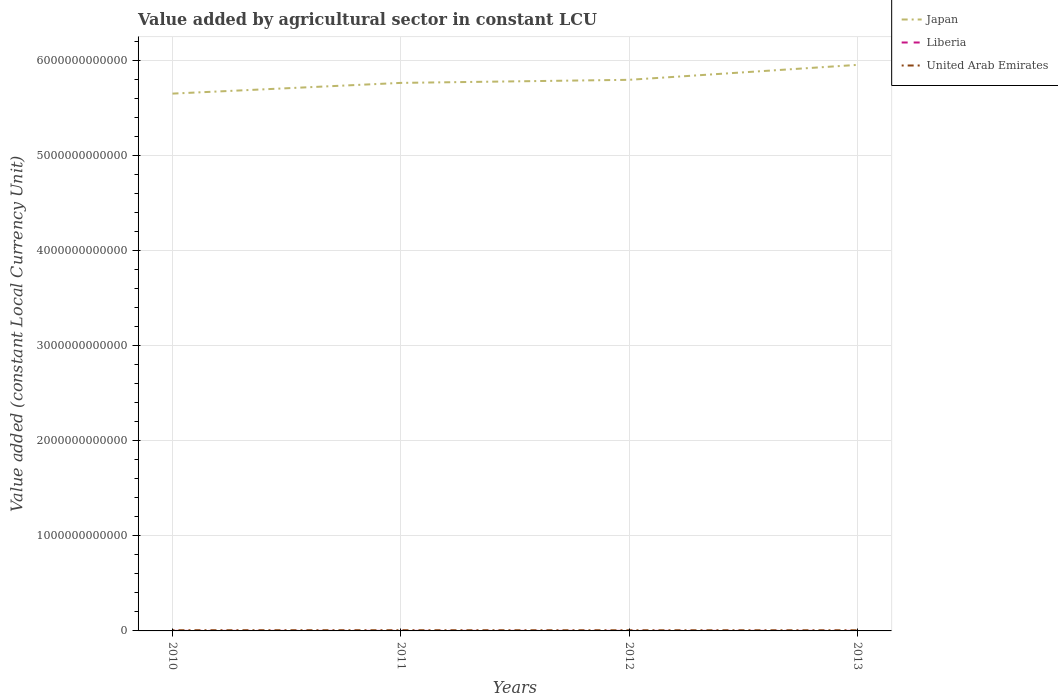How many different coloured lines are there?
Keep it short and to the point. 3. Does the line corresponding to United Arab Emirates intersect with the line corresponding to Japan?
Provide a succinct answer. No. Across all years, what is the maximum value added by agricultural sector in Japan?
Offer a terse response. 5.66e+12. What is the total value added by agricultural sector in Japan in the graph?
Offer a terse response. -1.13e+11. What is the difference between the highest and the second highest value added by agricultural sector in Liberia?
Offer a terse response. 2.97e+07. What is the difference between two consecutive major ticks on the Y-axis?
Provide a short and direct response. 1.00e+12. Are the values on the major ticks of Y-axis written in scientific E-notation?
Your response must be concise. No. Does the graph contain any zero values?
Make the answer very short. No. Where does the legend appear in the graph?
Keep it short and to the point. Top right. What is the title of the graph?
Make the answer very short. Value added by agricultural sector in constant LCU. Does "Angola" appear as one of the legend labels in the graph?
Offer a terse response. No. What is the label or title of the Y-axis?
Offer a terse response. Value added (constant Local Currency Unit). What is the Value added (constant Local Currency Unit) of Japan in 2010?
Keep it short and to the point. 5.66e+12. What is the Value added (constant Local Currency Unit) of Liberia in 2010?
Provide a succinct answer. 3.45e+08. What is the Value added (constant Local Currency Unit) in United Arab Emirates in 2010?
Make the answer very short. 7.35e+09. What is the Value added (constant Local Currency Unit) in Japan in 2011?
Keep it short and to the point. 5.77e+12. What is the Value added (constant Local Currency Unit) of Liberia in 2011?
Your answer should be very brief. 3.59e+08. What is the Value added (constant Local Currency Unit) of United Arab Emirates in 2011?
Offer a very short reply. 7.36e+09. What is the Value added (constant Local Currency Unit) of Japan in 2012?
Offer a terse response. 5.80e+12. What is the Value added (constant Local Currency Unit) in Liberia in 2012?
Offer a terse response. 3.66e+08. What is the Value added (constant Local Currency Unit) in United Arab Emirates in 2012?
Provide a short and direct response. 6.95e+09. What is the Value added (constant Local Currency Unit) in Japan in 2013?
Give a very brief answer. 5.96e+12. What is the Value added (constant Local Currency Unit) of Liberia in 2013?
Make the answer very short. 3.75e+08. What is the Value added (constant Local Currency Unit) of United Arab Emirates in 2013?
Your answer should be compact. 6.93e+09. Across all years, what is the maximum Value added (constant Local Currency Unit) in Japan?
Provide a succinct answer. 5.96e+12. Across all years, what is the maximum Value added (constant Local Currency Unit) of Liberia?
Offer a very short reply. 3.75e+08. Across all years, what is the maximum Value added (constant Local Currency Unit) in United Arab Emirates?
Your answer should be very brief. 7.36e+09. Across all years, what is the minimum Value added (constant Local Currency Unit) of Japan?
Offer a terse response. 5.66e+12. Across all years, what is the minimum Value added (constant Local Currency Unit) in Liberia?
Give a very brief answer. 3.45e+08. Across all years, what is the minimum Value added (constant Local Currency Unit) in United Arab Emirates?
Offer a very short reply. 6.93e+09. What is the total Value added (constant Local Currency Unit) of Japan in the graph?
Give a very brief answer. 2.32e+13. What is the total Value added (constant Local Currency Unit) of Liberia in the graph?
Your response must be concise. 1.45e+09. What is the total Value added (constant Local Currency Unit) in United Arab Emirates in the graph?
Your answer should be very brief. 2.86e+1. What is the difference between the Value added (constant Local Currency Unit) in Japan in 2010 and that in 2011?
Provide a succinct answer. -1.13e+11. What is the difference between the Value added (constant Local Currency Unit) in Liberia in 2010 and that in 2011?
Your answer should be very brief. -1.34e+07. What is the difference between the Value added (constant Local Currency Unit) of United Arab Emirates in 2010 and that in 2011?
Provide a succinct answer. -1.20e+07. What is the difference between the Value added (constant Local Currency Unit) in Japan in 2010 and that in 2012?
Keep it short and to the point. -1.45e+11. What is the difference between the Value added (constant Local Currency Unit) of Liberia in 2010 and that in 2012?
Provide a succinct answer. -2.03e+07. What is the difference between the Value added (constant Local Currency Unit) in United Arab Emirates in 2010 and that in 2012?
Offer a very short reply. 3.94e+08. What is the difference between the Value added (constant Local Currency Unit) in Japan in 2010 and that in 2013?
Your answer should be very brief. -3.02e+11. What is the difference between the Value added (constant Local Currency Unit) of Liberia in 2010 and that in 2013?
Give a very brief answer. -2.97e+07. What is the difference between the Value added (constant Local Currency Unit) in United Arab Emirates in 2010 and that in 2013?
Provide a short and direct response. 4.12e+08. What is the difference between the Value added (constant Local Currency Unit) of Japan in 2011 and that in 2012?
Make the answer very short. -3.24e+1. What is the difference between the Value added (constant Local Currency Unit) in Liberia in 2011 and that in 2012?
Give a very brief answer. -6.83e+06. What is the difference between the Value added (constant Local Currency Unit) of United Arab Emirates in 2011 and that in 2012?
Provide a short and direct response. 4.06e+08. What is the difference between the Value added (constant Local Currency Unit) of Japan in 2011 and that in 2013?
Your answer should be very brief. -1.90e+11. What is the difference between the Value added (constant Local Currency Unit) in Liberia in 2011 and that in 2013?
Provide a short and direct response. -1.62e+07. What is the difference between the Value added (constant Local Currency Unit) of United Arab Emirates in 2011 and that in 2013?
Your response must be concise. 4.24e+08. What is the difference between the Value added (constant Local Currency Unit) in Japan in 2012 and that in 2013?
Offer a very short reply. -1.57e+11. What is the difference between the Value added (constant Local Currency Unit) of Liberia in 2012 and that in 2013?
Provide a short and direct response. -9.39e+06. What is the difference between the Value added (constant Local Currency Unit) in United Arab Emirates in 2012 and that in 2013?
Make the answer very short. 1.80e+07. What is the difference between the Value added (constant Local Currency Unit) of Japan in 2010 and the Value added (constant Local Currency Unit) of Liberia in 2011?
Provide a succinct answer. 5.66e+12. What is the difference between the Value added (constant Local Currency Unit) in Japan in 2010 and the Value added (constant Local Currency Unit) in United Arab Emirates in 2011?
Your response must be concise. 5.65e+12. What is the difference between the Value added (constant Local Currency Unit) in Liberia in 2010 and the Value added (constant Local Currency Unit) in United Arab Emirates in 2011?
Offer a very short reply. -7.01e+09. What is the difference between the Value added (constant Local Currency Unit) in Japan in 2010 and the Value added (constant Local Currency Unit) in Liberia in 2012?
Your response must be concise. 5.66e+12. What is the difference between the Value added (constant Local Currency Unit) in Japan in 2010 and the Value added (constant Local Currency Unit) in United Arab Emirates in 2012?
Ensure brevity in your answer.  5.65e+12. What is the difference between the Value added (constant Local Currency Unit) in Liberia in 2010 and the Value added (constant Local Currency Unit) in United Arab Emirates in 2012?
Your response must be concise. -6.61e+09. What is the difference between the Value added (constant Local Currency Unit) in Japan in 2010 and the Value added (constant Local Currency Unit) in Liberia in 2013?
Your answer should be compact. 5.66e+12. What is the difference between the Value added (constant Local Currency Unit) of Japan in 2010 and the Value added (constant Local Currency Unit) of United Arab Emirates in 2013?
Offer a terse response. 5.65e+12. What is the difference between the Value added (constant Local Currency Unit) in Liberia in 2010 and the Value added (constant Local Currency Unit) in United Arab Emirates in 2013?
Your answer should be very brief. -6.59e+09. What is the difference between the Value added (constant Local Currency Unit) of Japan in 2011 and the Value added (constant Local Currency Unit) of Liberia in 2012?
Your answer should be very brief. 5.77e+12. What is the difference between the Value added (constant Local Currency Unit) of Japan in 2011 and the Value added (constant Local Currency Unit) of United Arab Emirates in 2012?
Your answer should be very brief. 5.76e+12. What is the difference between the Value added (constant Local Currency Unit) in Liberia in 2011 and the Value added (constant Local Currency Unit) in United Arab Emirates in 2012?
Your response must be concise. -6.59e+09. What is the difference between the Value added (constant Local Currency Unit) in Japan in 2011 and the Value added (constant Local Currency Unit) in Liberia in 2013?
Offer a very short reply. 5.77e+12. What is the difference between the Value added (constant Local Currency Unit) in Japan in 2011 and the Value added (constant Local Currency Unit) in United Arab Emirates in 2013?
Offer a terse response. 5.76e+12. What is the difference between the Value added (constant Local Currency Unit) of Liberia in 2011 and the Value added (constant Local Currency Unit) of United Arab Emirates in 2013?
Offer a very short reply. -6.58e+09. What is the difference between the Value added (constant Local Currency Unit) in Japan in 2012 and the Value added (constant Local Currency Unit) in Liberia in 2013?
Give a very brief answer. 5.80e+12. What is the difference between the Value added (constant Local Currency Unit) in Japan in 2012 and the Value added (constant Local Currency Unit) in United Arab Emirates in 2013?
Provide a short and direct response. 5.79e+12. What is the difference between the Value added (constant Local Currency Unit) in Liberia in 2012 and the Value added (constant Local Currency Unit) in United Arab Emirates in 2013?
Provide a short and direct response. -6.57e+09. What is the average Value added (constant Local Currency Unit) in Japan per year?
Your answer should be compact. 5.80e+12. What is the average Value added (constant Local Currency Unit) of Liberia per year?
Provide a short and direct response. 3.61e+08. What is the average Value added (constant Local Currency Unit) in United Arab Emirates per year?
Your answer should be very brief. 7.15e+09. In the year 2010, what is the difference between the Value added (constant Local Currency Unit) in Japan and Value added (constant Local Currency Unit) in Liberia?
Make the answer very short. 5.66e+12. In the year 2010, what is the difference between the Value added (constant Local Currency Unit) of Japan and Value added (constant Local Currency Unit) of United Arab Emirates?
Give a very brief answer. 5.65e+12. In the year 2010, what is the difference between the Value added (constant Local Currency Unit) of Liberia and Value added (constant Local Currency Unit) of United Arab Emirates?
Keep it short and to the point. -7.00e+09. In the year 2011, what is the difference between the Value added (constant Local Currency Unit) of Japan and Value added (constant Local Currency Unit) of Liberia?
Provide a succinct answer. 5.77e+12. In the year 2011, what is the difference between the Value added (constant Local Currency Unit) in Japan and Value added (constant Local Currency Unit) in United Arab Emirates?
Provide a succinct answer. 5.76e+12. In the year 2011, what is the difference between the Value added (constant Local Currency Unit) in Liberia and Value added (constant Local Currency Unit) in United Arab Emirates?
Make the answer very short. -7.00e+09. In the year 2012, what is the difference between the Value added (constant Local Currency Unit) of Japan and Value added (constant Local Currency Unit) of Liberia?
Give a very brief answer. 5.80e+12. In the year 2012, what is the difference between the Value added (constant Local Currency Unit) in Japan and Value added (constant Local Currency Unit) in United Arab Emirates?
Provide a succinct answer. 5.79e+12. In the year 2012, what is the difference between the Value added (constant Local Currency Unit) of Liberia and Value added (constant Local Currency Unit) of United Arab Emirates?
Offer a very short reply. -6.59e+09. In the year 2013, what is the difference between the Value added (constant Local Currency Unit) of Japan and Value added (constant Local Currency Unit) of Liberia?
Offer a very short reply. 5.96e+12. In the year 2013, what is the difference between the Value added (constant Local Currency Unit) of Japan and Value added (constant Local Currency Unit) of United Arab Emirates?
Ensure brevity in your answer.  5.95e+12. In the year 2013, what is the difference between the Value added (constant Local Currency Unit) of Liberia and Value added (constant Local Currency Unit) of United Arab Emirates?
Provide a succinct answer. -6.56e+09. What is the ratio of the Value added (constant Local Currency Unit) of Japan in 2010 to that in 2011?
Your response must be concise. 0.98. What is the ratio of the Value added (constant Local Currency Unit) of Liberia in 2010 to that in 2011?
Offer a very short reply. 0.96. What is the ratio of the Value added (constant Local Currency Unit) of United Arab Emirates in 2010 to that in 2011?
Your answer should be compact. 1. What is the ratio of the Value added (constant Local Currency Unit) of Liberia in 2010 to that in 2012?
Your answer should be very brief. 0.94. What is the ratio of the Value added (constant Local Currency Unit) in United Arab Emirates in 2010 to that in 2012?
Your answer should be very brief. 1.06. What is the ratio of the Value added (constant Local Currency Unit) of Japan in 2010 to that in 2013?
Provide a short and direct response. 0.95. What is the ratio of the Value added (constant Local Currency Unit) in Liberia in 2010 to that in 2013?
Offer a very short reply. 0.92. What is the ratio of the Value added (constant Local Currency Unit) of United Arab Emirates in 2010 to that in 2013?
Provide a succinct answer. 1.06. What is the ratio of the Value added (constant Local Currency Unit) of Liberia in 2011 to that in 2012?
Provide a succinct answer. 0.98. What is the ratio of the Value added (constant Local Currency Unit) in United Arab Emirates in 2011 to that in 2012?
Your answer should be compact. 1.06. What is the ratio of the Value added (constant Local Currency Unit) in Japan in 2011 to that in 2013?
Give a very brief answer. 0.97. What is the ratio of the Value added (constant Local Currency Unit) in Liberia in 2011 to that in 2013?
Provide a short and direct response. 0.96. What is the ratio of the Value added (constant Local Currency Unit) of United Arab Emirates in 2011 to that in 2013?
Keep it short and to the point. 1.06. What is the ratio of the Value added (constant Local Currency Unit) in Japan in 2012 to that in 2013?
Offer a terse response. 0.97. What is the difference between the highest and the second highest Value added (constant Local Currency Unit) in Japan?
Provide a short and direct response. 1.57e+11. What is the difference between the highest and the second highest Value added (constant Local Currency Unit) in Liberia?
Provide a short and direct response. 9.39e+06. What is the difference between the highest and the second highest Value added (constant Local Currency Unit) in United Arab Emirates?
Give a very brief answer. 1.20e+07. What is the difference between the highest and the lowest Value added (constant Local Currency Unit) in Japan?
Your answer should be very brief. 3.02e+11. What is the difference between the highest and the lowest Value added (constant Local Currency Unit) in Liberia?
Provide a succinct answer. 2.97e+07. What is the difference between the highest and the lowest Value added (constant Local Currency Unit) of United Arab Emirates?
Your answer should be compact. 4.24e+08. 